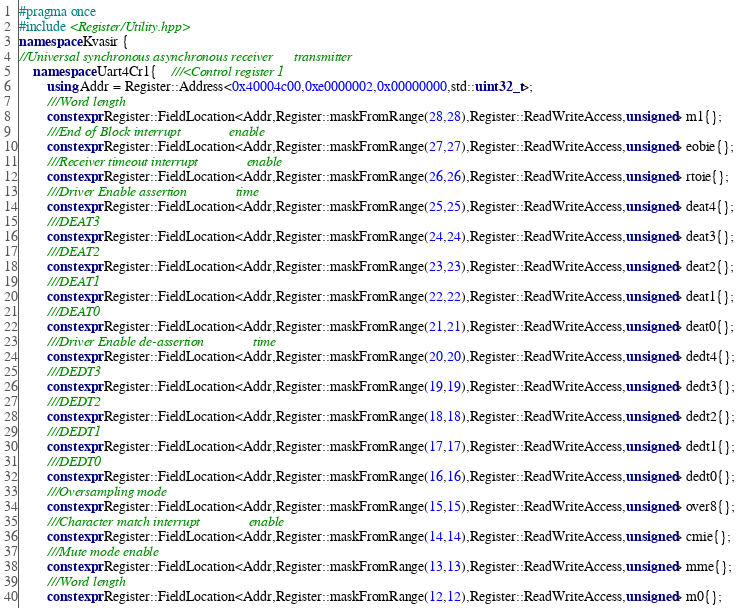<code> <loc_0><loc_0><loc_500><loc_500><_C++_>#pragma once 
#include <Register/Utility.hpp>
namespace Kvasir {
//Universal synchronous asynchronous receiver      transmitter
    namespace Uart4Cr1{    ///<Control register 1
        using Addr = Register::Address<0x40004c00,0xe0000002,0x00000000,std::uint32_t>;
        ///Word length
        constexpr Register::FieldLocation<Addr,Register::maskFromRange(28,28),Register::ReadWriteAccess,unsigned> m1{}; 
        ///End of Block interrupt              enable
        constexpr Register::FieldLocation<Addr,Register::maskFromRange(27,27),Register::ReadWriteAccess,unsigned> eobie{}; 
        ///Receiver timeout interrupt              enable
        constexpr Register::FieldLocation<Addr,Register::maskFromRange(26,26),Register::ReadWriteAccess,unsigned> rtoie{}; 
        ///Driver Enable assertion              time
        constexpr Register::FieldLocation<Addr,Register::maskFromRange(25,25),Register::ReadWriteAccess,unsigned> deat4{}; 
        ///DEAT3
        constexpr Register::FieldLocation<Addr,Register::maskFromRange(24,24),Register::ReadWriteAccess,unsigned> deat3{}; 
        ///DEAT2
        constexpr Register::FieldLocation<Addr,Register::maskFromRange(23,23),Register::ReadWriteAccess,unsigned> deat2{}; 
        ///DEAT1
        constexpr Register::FieldLocation<Addr,Register::maskFromRange(22,22),Register::ReadWriteAccess,unsigned> deat1{}; 
        ///DEAT0
        constexpr Register::FieldLocation<Addr,Register::maskFromRange(21,21),Register::ReadWriteAccess,unsigned> deat0{}; 
        ///Driver Enable de-assertion              time
        constexpr Register::FieldLocation<Addr,Register::maskFromRange(20,20),Register::ReadWriteAccess,unsigned> dedt4{}; 
        ///DEDT3
        constexpr Register::FieldLocation<Addr,Register::maskFromRange(19,19),Register::ReadWriteAccess,unsigned> dedt3{}; 
        ///DEDT2
        constexpr Register::FieldLocation<Addr,Register::maskFromRange(18,18),Register::ReadWriteAccess,unsigned> dedt2{}; 
        ///DEDT1
        constexpr Register::FieldLocation<Addr,Register::maskFromRange(17,17),Register::ReadWriteAccess,unsigned> dedt1{}; 
        ///DEDT0
        constexpr Register::FieldLocation<Addr,Register::maskFromRange(16,16),Register::ReadWriteAccess,unsigned> dedt0{}; 
        ///Oversampling mode
        constexpr Register::FieldLocation<Addr,Register::maskFromRange(15,15),Register::ReadWriteAccess,unsigned> over8{}; 
        ///Character match interrupt              enable
        constexpr Register::FieldLocation<Addr,Register::maskFromRange(14,14),Register::ReadWriteAccess,unsigned> cmie{}; 
        ///Mute mode enable
        constexpr Register::FieldLocation<Addr,Register::maskFromRange(13,13),Register::ReadWriteAccess,unsigned> mme{}; 
        ///Word length
        constexpr Register::FieldLocation<Addr,Register::maskFromRange(12,12),Register::ReadWriteAccess,unsigned> m0{}; </code> 